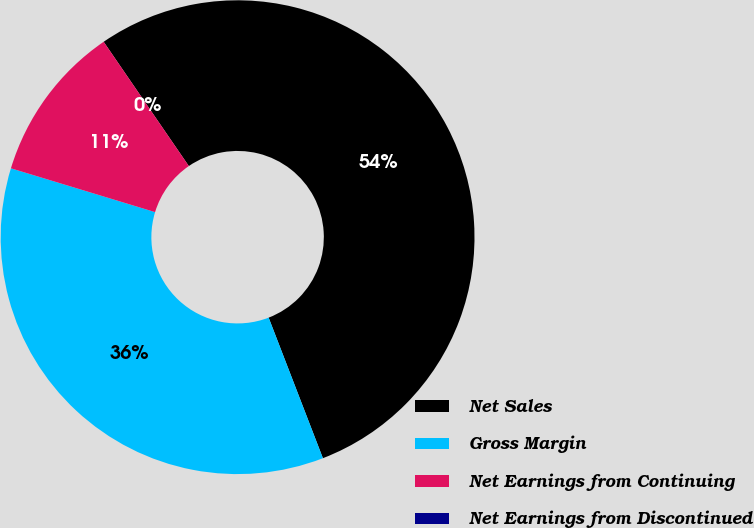<chart> <loc_0><loc_0><loc_500><loc_500><pie_chart><fcel>Net Sales<fcel>Gross Margin<fcel>Net Earnings from Continuing<fcel>Net Earnings from Discontinued<nl><fcel>53.7%<fcel>35.56%<fcel>10.74%<fcel>0.0%<nl></chart> 